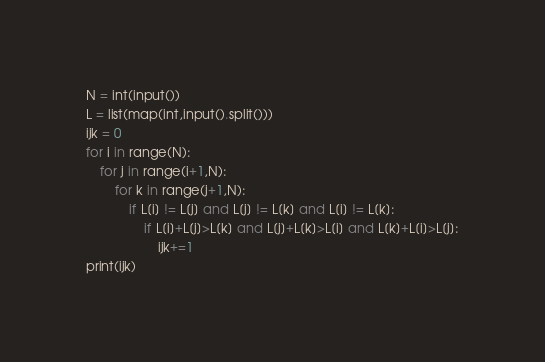Convert code to text. <code><loc_0><loc_0><loc_500><loc_500><_Python_>N = int(input())
L = list(map(int,input().split()))
ijk = 0
for i in range(N):
    for j in range(i+1,N):
        for k in range(j+1,N):
            if L[i] != L[j] and L[j] != L[k] and L[i] != L[k]:
                if L[i]+L[j]>L[k] and L[j]+L[k]>L[i] and L[k]+L[i]>L[j]:
                    ijk+=1
print(ijk)</code> 